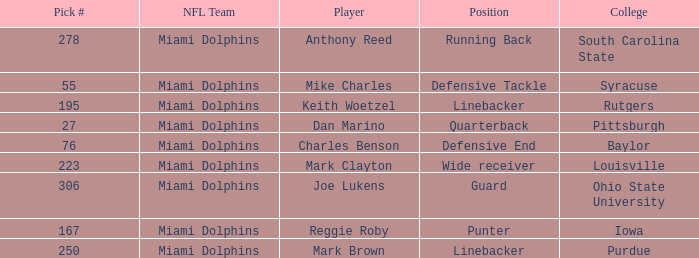Which Position has a Pick # lower than 278 for Player Charles Benson? Defensive End. 